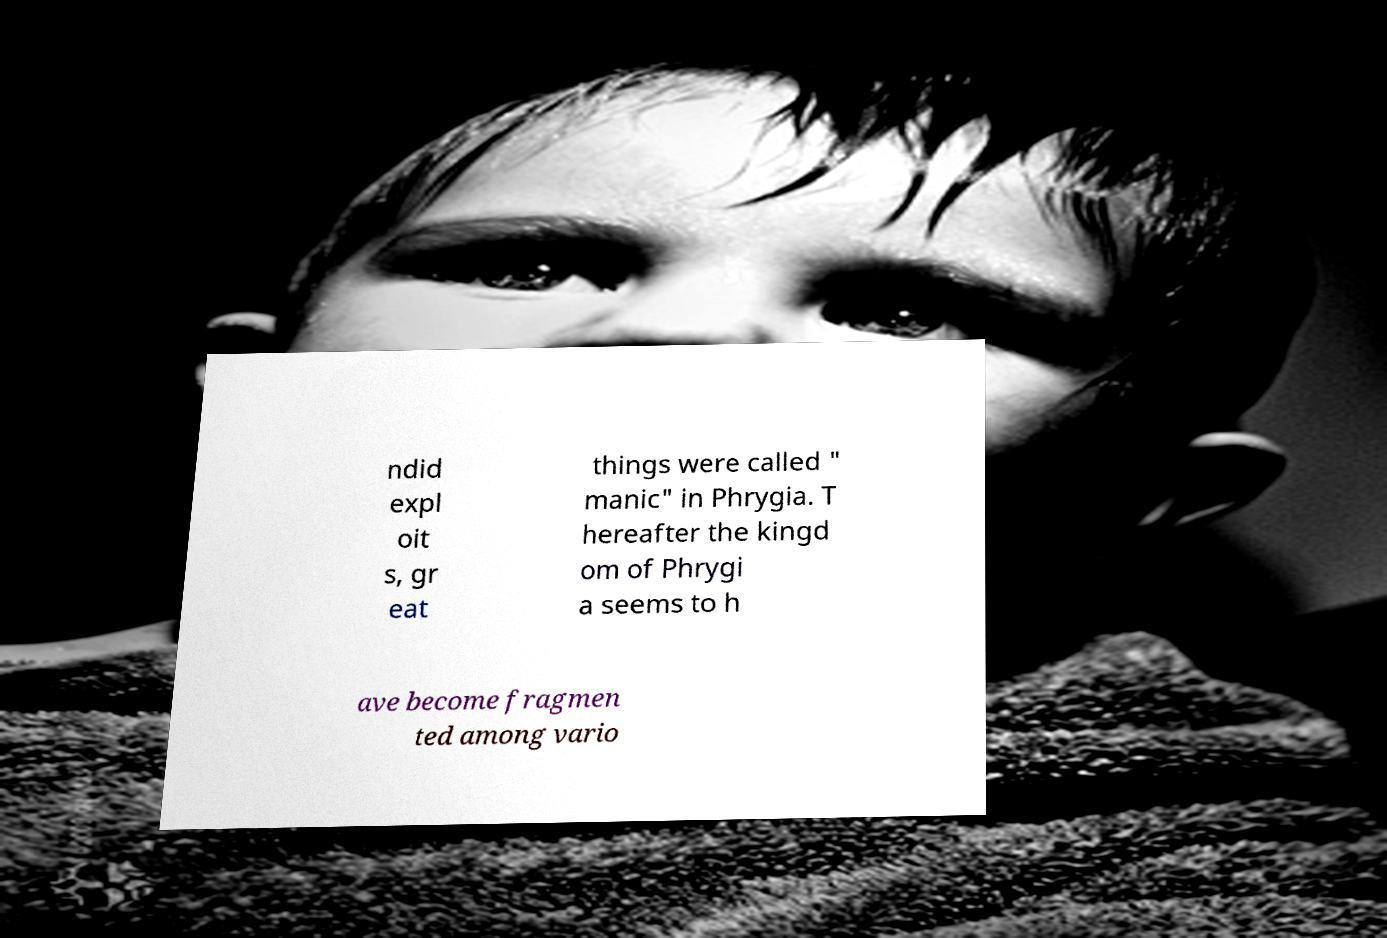For documentation purposes, I need the text within this image transcribed. Could you provide that? ndid expl oit s, gr eat things were called " manic" in Phrygia. T hereafter the kingd om of Phrygi a seems to h ave become fragmen ted among vario 